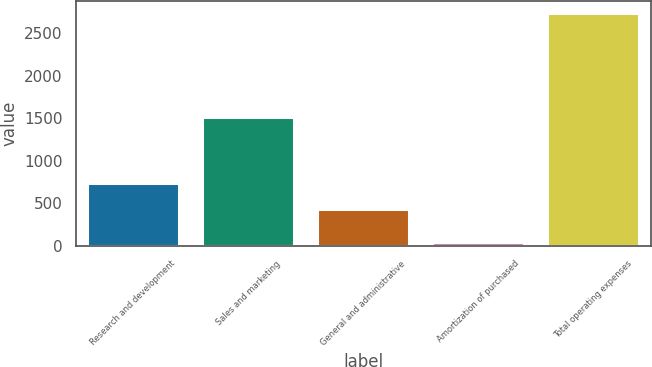Convert chart. <chart><loc_0><loc_0><loc_500><loc_500><bar_chart><fcel>Research and development<fcel>Sales and marketing<fcel>General and administrative<fcel>Amortization of purchased<fcel>Total operating expenses<nl><fcel>742.8<fcel>1516.1<fcel>435<fcel>48.7<fcel>2739.7<nl></chart> 